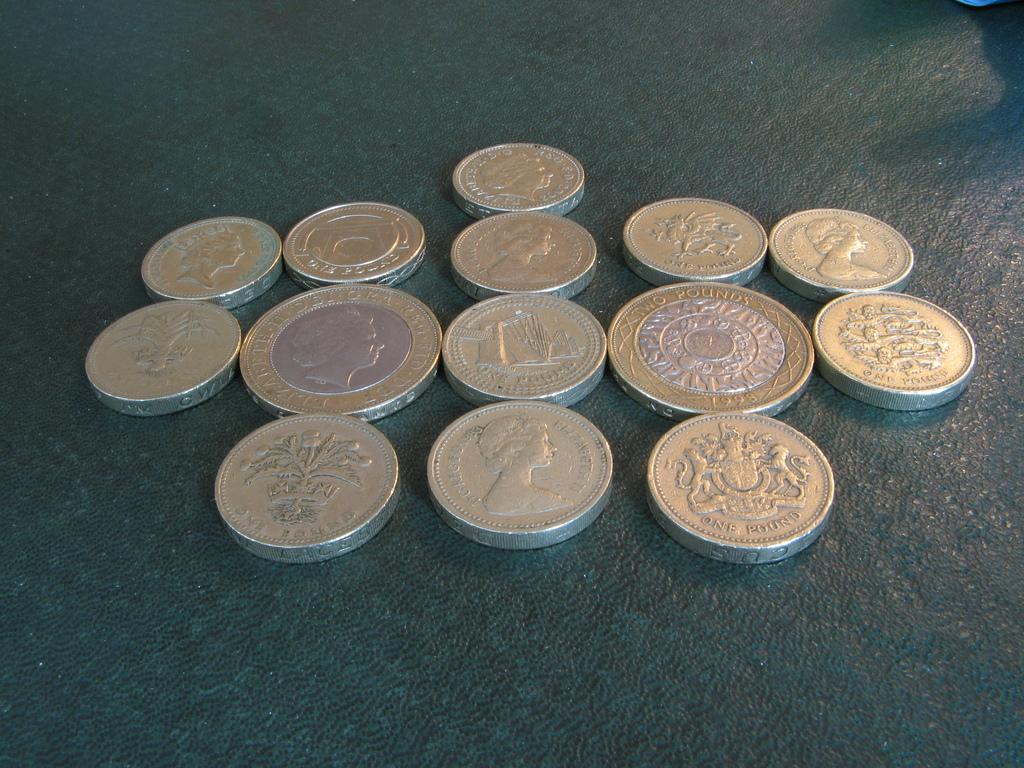How much are one of these coins worth?
Keep it short and to the point. One pound. This collection of dollars?
Offer a terse response. Yes. 